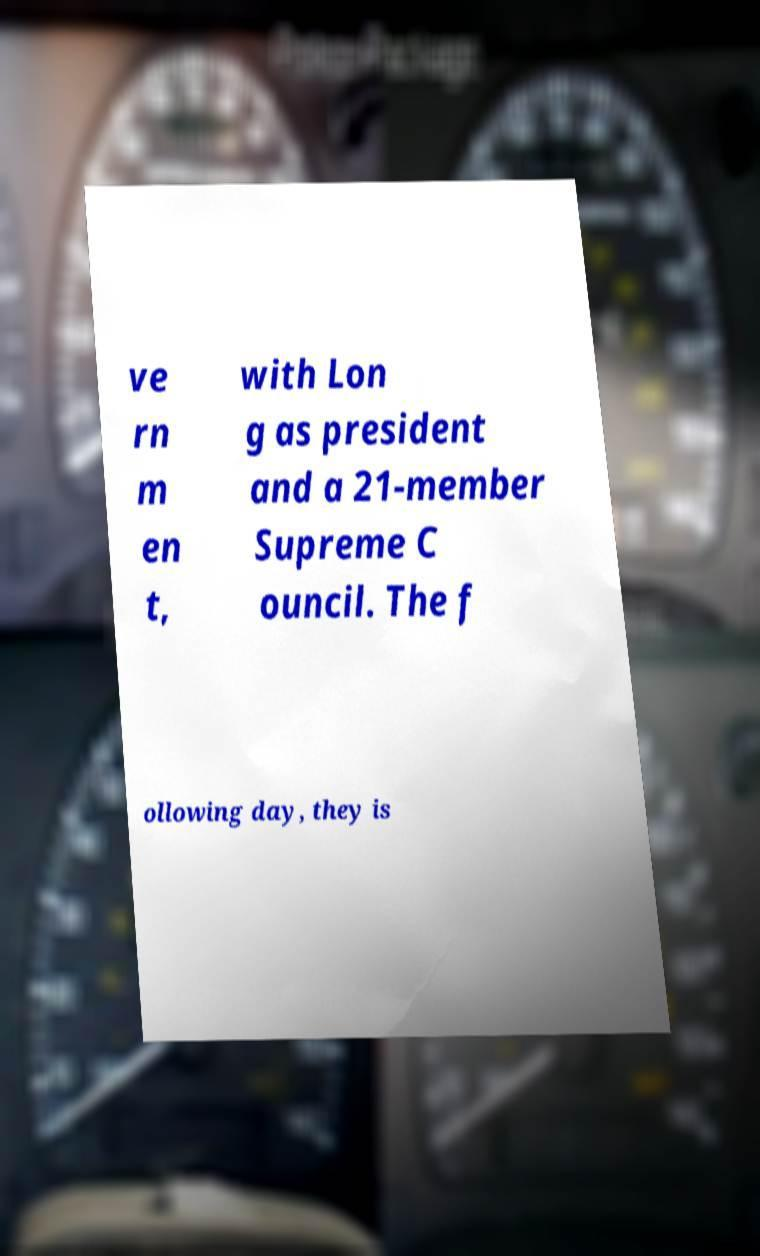Could you extract and type out the text from this image? ve rn m en t, with Lon g as president and a 21-member Supreme C ouncil. The f ollowing day, they is 